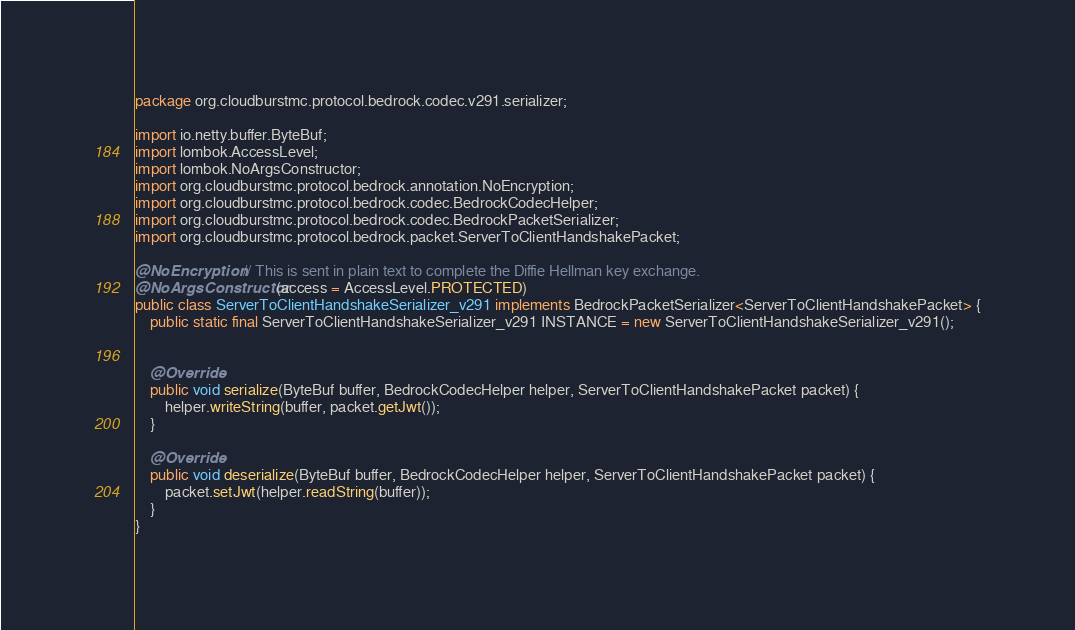Convert code to text. <code><loc_0><loc_0><loc_500><loc_500><_Java_>package org.cloudburstmc.protocol.bedrock.codec.v291.serializer;

import io.netty.buffer.ByteBuf;
import lombok.AccessLevel;
import lombok.NoArgsConstructor;
import org.cloudburstmc.protocol.bedrock.annotation.NoEncryption;
import org.cloudburstmc.protocol.bedrock.codec.BedrockCodecHelper;
import org.cloudburstmc.protocol.bedrock.codec.BedrockPacketSerializer;
import org.cloudburstmc.protocol.bedrock.packet.ServerToClientHandshakePacket;

@NoEncryption // This is sent in plain text to complete the Diffie Hellman key exchange.
@NoArgsConstructor(access = AccessLevel.PROTECTED)
public class ServerToClientHandshakeSerializer_v291 implements BedrockPacketSerializer<ServerToClientHandshakePacket> {
    public static final ServerToClientHandshakeSerializer_v291 INSTANCE = new ServerToClientHandshakeSerializer_v291();


    @Override
    public void serialize(ByteBuf buffer, BedrockCodecHelper helper, ServerToClientHandshakePacket packet) {
        helper.writeString(buffer, packet.getJwt());
    }

    @Override
    public void deserialize(ByteBuf buffer, BedrockCodecHelper helper, ServerToClientHandshakePacket packet) {
        packet.setJwt(helper.readString(buffer));
    }
}
</code> 